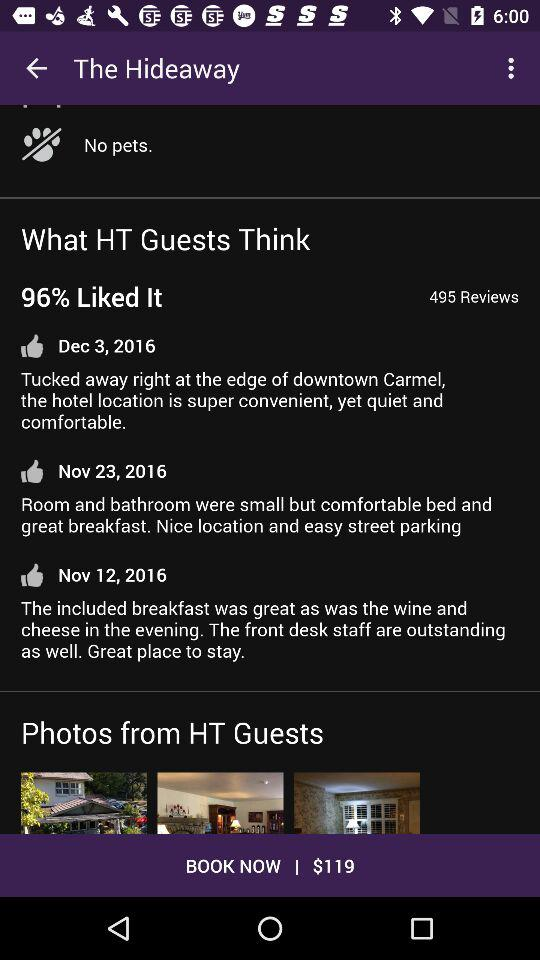What is the given number of reviews? The given number of reviews is 495. 